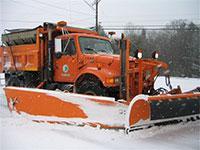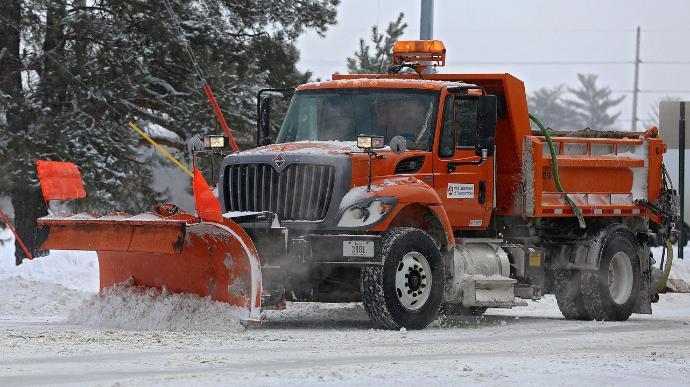The first image is the image on the left, the second image is the image on the right. Analyze the images presented: Is the assertion "The left and right image contains the same number of snow dump trunks." valid? Answer yes or no. Yes. The first image is the image on the left, the second image is the image on the right. Evaluate the accuracy of this statement regarding the images: "Both plows are attached to large trucks and have visible snow on them.". Is it true? Answer yes or no. Yes. 